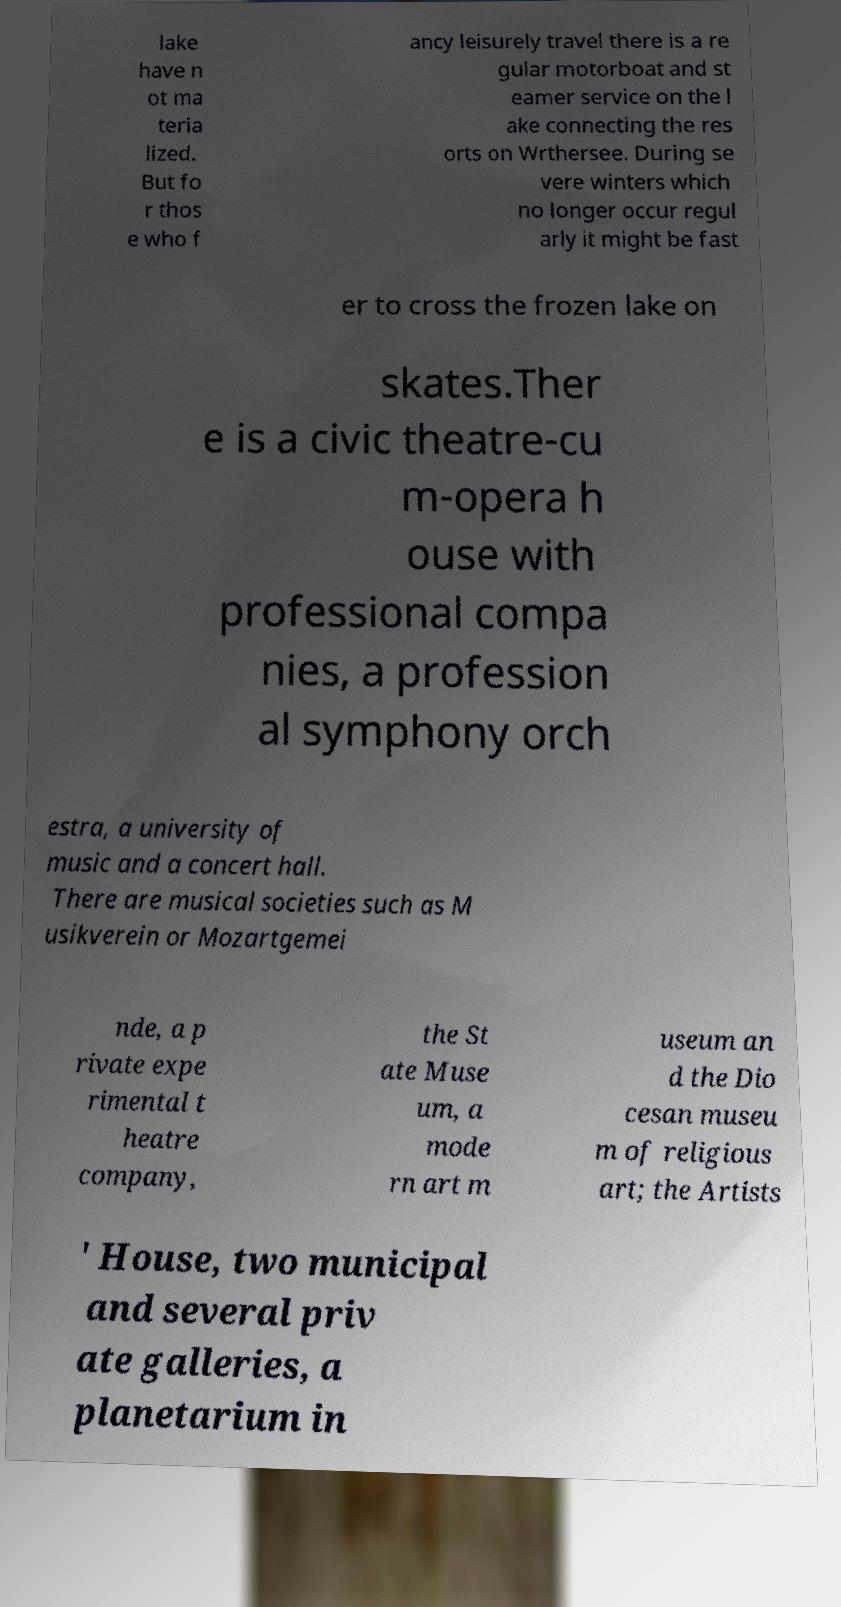Can you accurately transcribe the text from the provided image for me? lake have n ot ma teria lized. But fo r thos e who f ancy leisurely travel there is a re gular motorboat and st eamer service on the l ake connecting the res orts on Wrthersee. During se vere winters which no longer occur regul arly it might be fast er to cross the frozen lake on skates.Ther e is a civic theatre-cu m-opera h ouse with professional compa nies, a profession al symphony orch estra, a university of music and a concert hall. There are musical societies such as M usikverein or Mozartgemei nde, a p rivate expe rimental t heatre company, the St ate Muse um, a mode rn art m useum an d the Dio cesan museu m of religious art; the Artists ' House, two municipal and several priv ate galleries, a planetarium in 